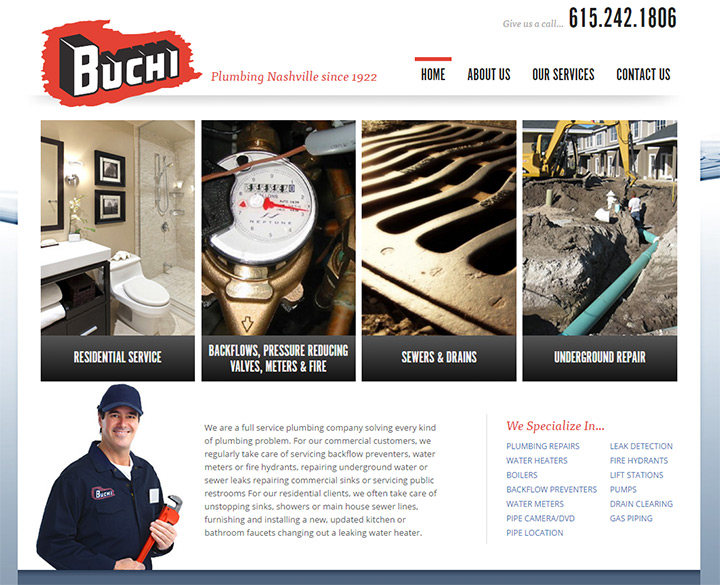Can you describe the target audience for this website based on its design elements? The design elements of this website suggest that the target audience includes both residential and commercial clients in need of comprehensive plumbing services. The clean and professional layout appeals to homeowners seeking reliable residential plumbing solutions, while the detailed sections on specialized services like backflows, pressure reducing valves, meters, and underground repair indicate a focus on commercial clients as well. The straightforward navigation and prominent contact information cater to busy professionals who need quick and efficient access to service details. This dual approach ensures that the company effectively addresses the needs of a diverse clientele, emphasizing trust, expertise, and accessibility. 